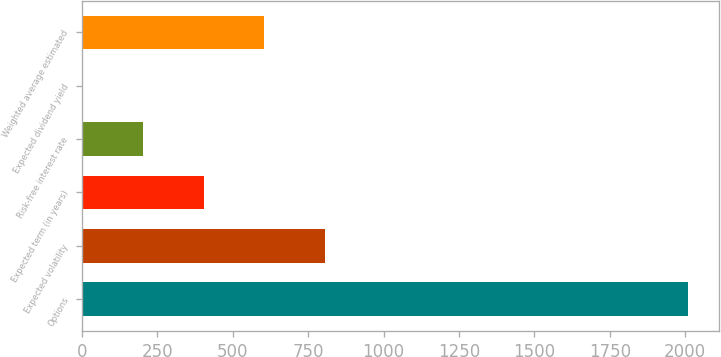Convert chart to OTSL. <chart><loc_0><loc_0><loc_500><loc_500><bar_chart><fcel>Options<fcel>Expected volatility<fcel>Expected term (in years)<fcel>Risk-free interest rate<fcel>Expected dividend yield<fcel>Weighted average estimated<nl><fcel>2010<fcel>805.37<fcel>403.81<fcel>203.03<fcel>2.25<fcel>604.59<nl></chart> 